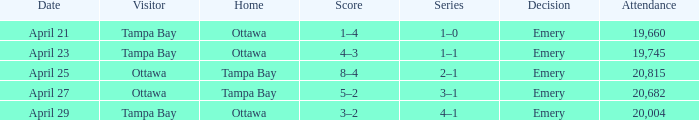What is the date of the game when attendance is more than 20,682? April 25. 